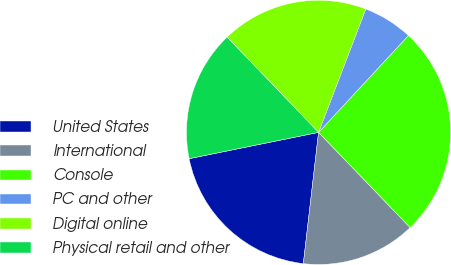Convert chart to OTSL. <chart><loc_0><loc_0><loc_500><loc_500><pie_chart><fcel>United States<fcel>International<fcel>Console<fcel>PC and other<fcel>Digital online<fcel>Physical retail and other<nl><fcel>19.97%<fcel>14.03%<fcel>25.9%<fcel>6.09%<fcel>17.99%<fcel>16.01%<nl></chart> 